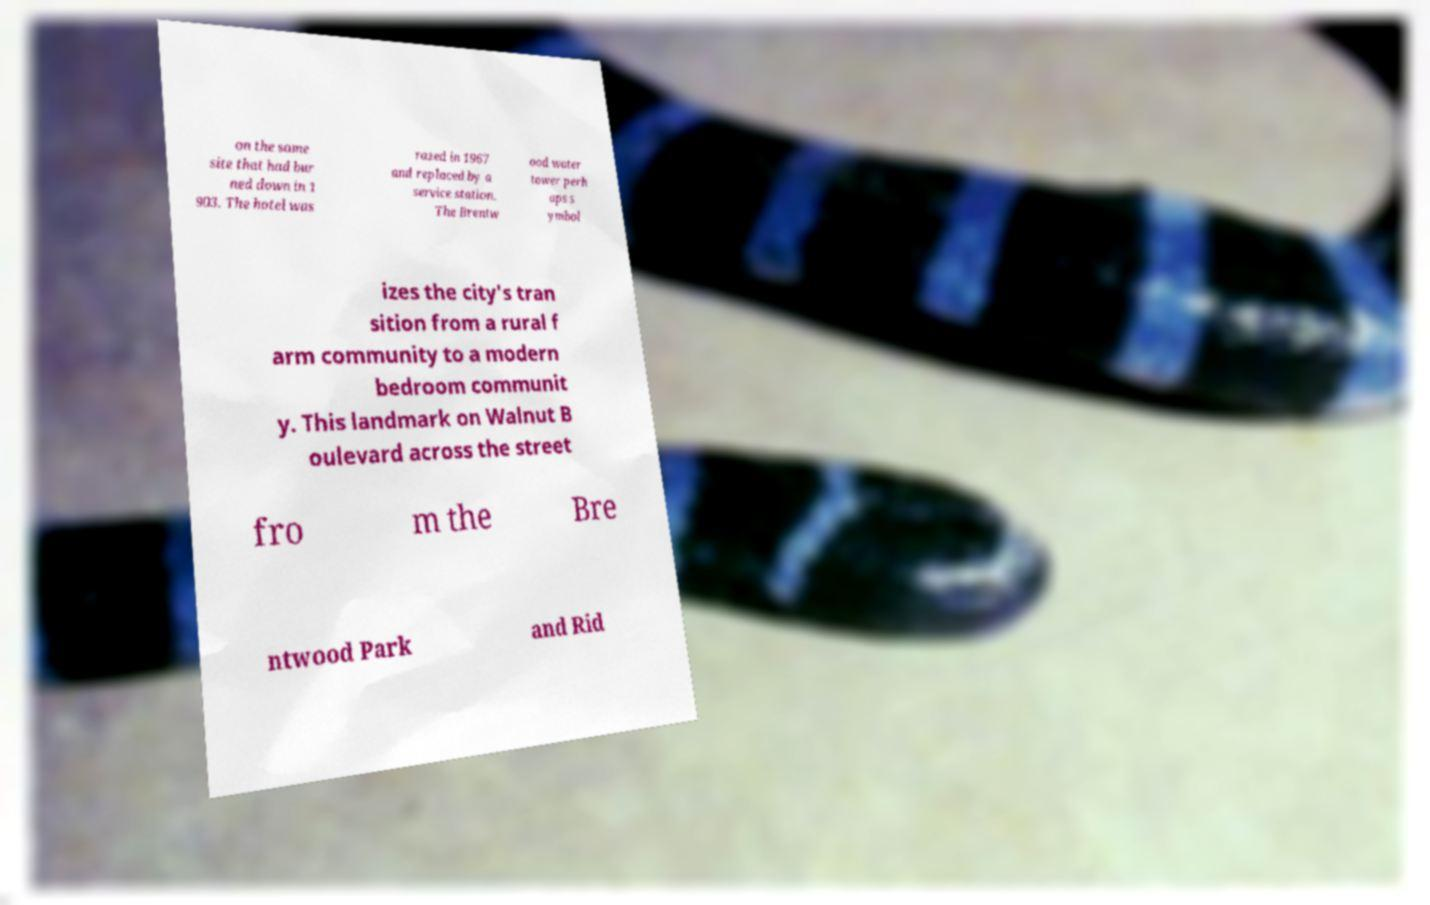Please identify and transcribe the text found in this image. on the same site that had bur ned down in 1 903. The hotel was razed in 1967 and replaced by a service station. The Brentw ood water tower perh aps s ymbol izes the city's tran sition from a rural f arm community to a modern bedroom communit y. This landmark on Walnut B oulevard across the street fro m the Bre ntwood Park and Rid 